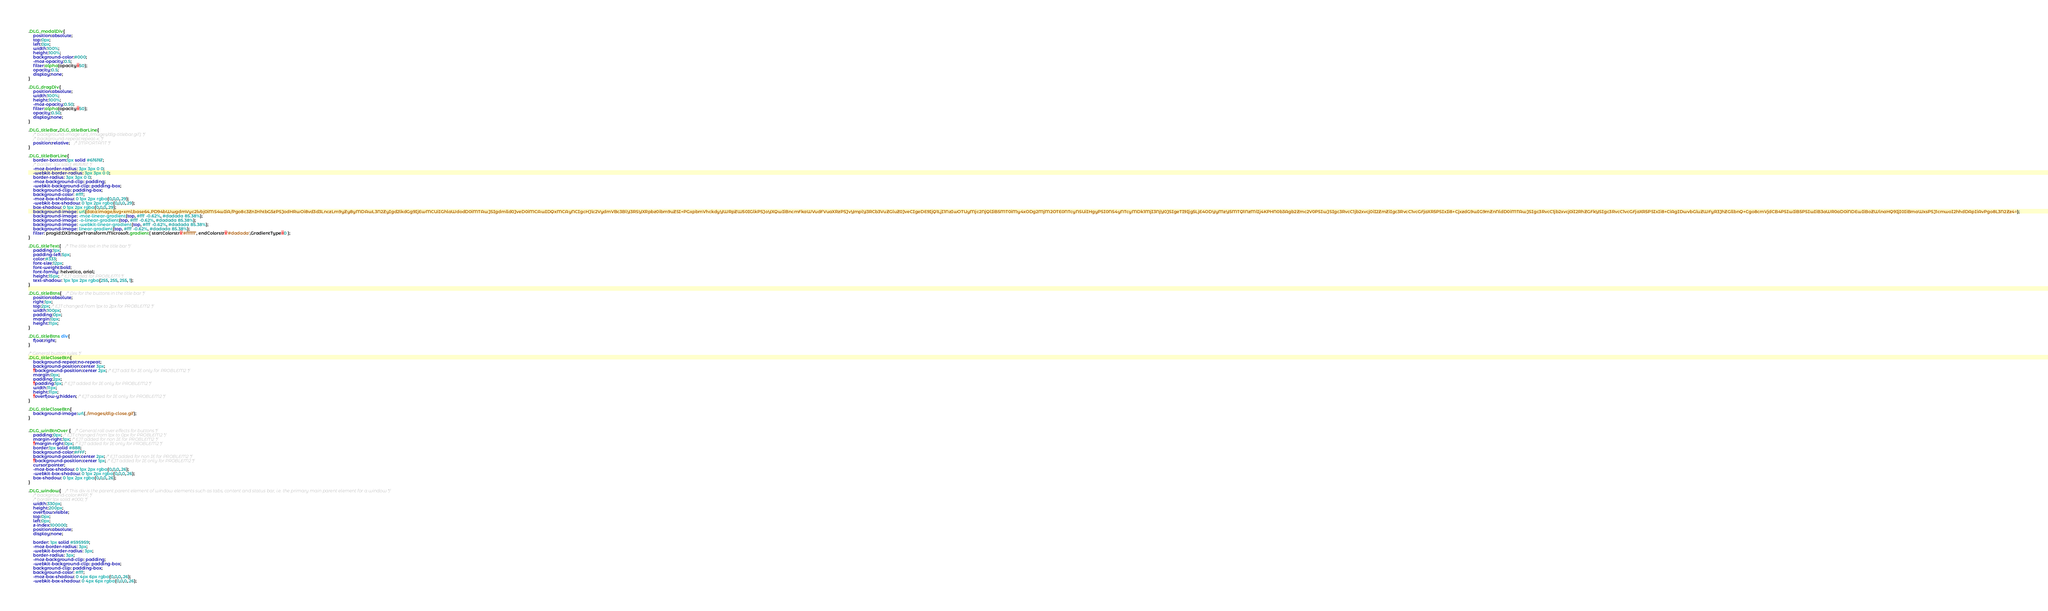Convert code to text. <code><loc_0><loc_0><loc_500><loc_500><_CSS_>
.DLG_modalDiv{
	position:absolute;
	top:0px;
	left:0px;
	width:100%;
	height:100%;
	background-color:#000;
	-moz-opacity:0.5;
	filter:alpha(opacity=50);
	opacity:0.5;
	display:none;
}

.DLG_dragDiv{
	position:absolute;
	width:100%;
	height:100%;
	-moz-opacity:0.50;
	filter:alpha(opacity=50);
	opacity:0.50;
	display:none;
}

.DLG_titleBar,.DLG_titleBarLine{
	/* background-image:url(./images/dlg-titlebar.gif); */
	/* background-repeat:repeat-x; */
	position:relative;	/* IMPORTANT */
}

.DLG_titleBarLine{
	border-bottom:1px solid #6f6f6f;	
	/* border: 1px solid #6f6f6f; */
	-moz-border-radius: 3px 3px 0 0;
	-webkit-border-radius: 3px 3px 0 0;
	border-radius: 3px 3px 0 0;
	-moz-background-clip: padding;
	-webkit-background-clip: padding-box;
	background-clip: padding-box;
	background-color: #fff;
	-moz-box-shadow: 0 1px 2px rgba(0,0,0,.29);
	-webkit-box-shadow: 0 1px 2px rgba(0,0,0,.29);
	box-shadow: 0 1px 2px rgba(0,0,0,.29);
	background-image: url(data:image/svg+xml;base64,PD94bWwgdmVyc2lvbj0iMS4wIiA/Pgo8c3ZnIHhtbG5zPSJodHRwOi8vd3d3LnczLm9yZy8yMDAwL3N2ZyIgd2lkdGg9IjEwMCUiIGhlaWdodD0iMTAwJSIgdmlld0JveD0iMCAwIDQxMCAyNCIgcHJlc2VydmVBc3BlY3RSYXRpbz0ibm9uZSI+PGxpbmVhckdyYWRpZW50IGlkPSJoYXQwIiBncmFkaWVudFVuaXRzPSJvYmplY3RCb3VuZGluZ0JveCIgeDE9IjQ1LjI1NzIwOTUyMjc2NjQlIiB5MT0iMy4xODg2MjM2OTE0NTcyNSUiIHgyPSI0NS4yNTcyMDk1MjI3NjY0JSIgeTI9Ijg5LjE4ODYyMzY5MTQ1NzMlIj4KPHN0b3Agb2Zmc2V0PSIwJSIgc3RvcC1jb2xvcj0iI2ZmZiIgc3RvcC1vcGFjaXR5PSIxIi8+CjxzdG9wIG9mZnNldD0iMTAwJSIgc3RvcC1jb2xvcj0iI2RhZGFkYSIgc3RvcC1vcGFjaXR5PSIxIi8+CiAgIDwvbGluZWFyR3JhZGllbnQ+Cgo8cmVjdCB4PSIwIiB5PSIwIiB3aWR0aD0iNDEwIiBoZWlnaHQ9IjI0IiBmaWxsPSJ1cmwoI2hhdDApIiAvPgo8L3N2Zz4=);
	background-image: -moz-linear-gradient(top, #fff -0.62%, #dadada 85.38%);
	background-image: -o-linear-gradient(top, #fff -0.62%, #dadada 85.38%);
	background-image: -webkit-linear-gradient(top, #fff -0.62%, #dadada 85.38%);
	background-image: linear-gradient(top, #fff -0.62%, #dadada 85.38%);
	filter: progid:DXImageTransform.Microsoft.gradient( startColorstr='#ffffff', endColorstr='#dadada',GradientType=0 );
}

.DLG_titleText{	/* The title text in the title bar */
	padding:1px;
	padding-left:5px;
	color:#333;
	font-size:12px;
	font-weight:bold;
	font-family: helvetica, arial;
	height:15px; /* EJT added for PROBLEM1 */
	text-shadow: 1px 1px 2px rgba(255, 255, 255, 1);
}

.DLG_titleBtns{	/* Div for the buttons in the title bar */
	position:absolute;
	right:1px;
	top:2px; /* EJT changed from 1px to 2px for PROBLEM2 */
	width:100px;
	padding:0px;
	margin:0px;
	height:11px;
}

.DLG_titleBtns div{
	float:right;
}

/* General button rules */
.DLG_titleCloseBtn{
	background-repeat:no-repeat;
	background-position:center 3px;
	*background-position:center 2px; /* EJT add for IE only for PROBLEM2 */
	margin:0px;
	padding:2px;
	*padding:1px; /* EJT added for IE only for PROBLEM2 */
	width:11px;
	height:11px;
	*overflow-y:hidden; /* EJT added for IE only for PROBLEM2 */
}

.DLG_titleCloseBtn{
	background-image:url(./images/dlg-close.gif);
}


.DLG_winBtnOver {	/* General roll over effects for buttons */
	padding:0px; /* EJT changed from 1px to 0px for PROBLEM2 */
	margin-right:1px; /* EJT added for non IE for PROBLEM2 */
	*margin-right:0px; /* EJT added for IE only for PROBLEM2 */
	border:1px solid #888;
	background-color:#FFF;
	background-position:center 2px; /* EJT added for non IE for PROBLEM2 */
	*background-position:center 1px; /* EJT added for IE only for PROBLEM2 */
	cursor:pointer;
	-moz-box-shadow: 0 1px 2px rgba(0,0,0,.26);
	-webkit-box-shadow: 0 1px 2px rgba(0,0,0,.26);
	box-shadow: 0 1px 2px rgba(0,0,0,.26);
}

.DLG_window{	/* This div is the parent parent element of window elements such as tabs, content and status bar, i.e. the primary main parent element for a window */
	/* background-color:#FFF; */
	/* border:1px solid #000; */
	width:330px;
	height:200px;
	overflow:visible;
	top:0px;
	left:0px;
	z-index:100000;
	position:absolute;
	display:none;
	
	border: 1px solid #595959;
	-moz-border-radius: 3px;
	-webkit-border-radius: 3px;
	border-radius: 3px;
	-moz-background-clip: padding;
	-webkit-background-clip: padding-box;
	background-clip: padding-box;
	background-color: #fff;
	-moz-box-shadow: 0 4px 6px rgba(0,0,0,.26);
	-webkit-box-shadow: 0 4px 6px rgba(0,0,0,.26);</code> 